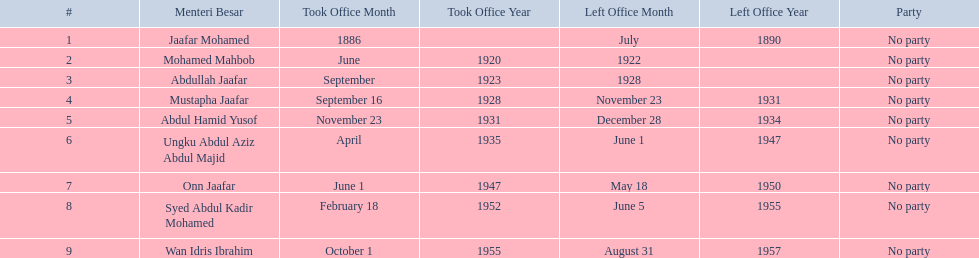Which menteri besars took office in the 1920's? Mohamed Mahbob, Abdullah Jaafar, Mustapha Jaafar. Of those men, who was only in office for 2 years? Mohamed Mahbob. 